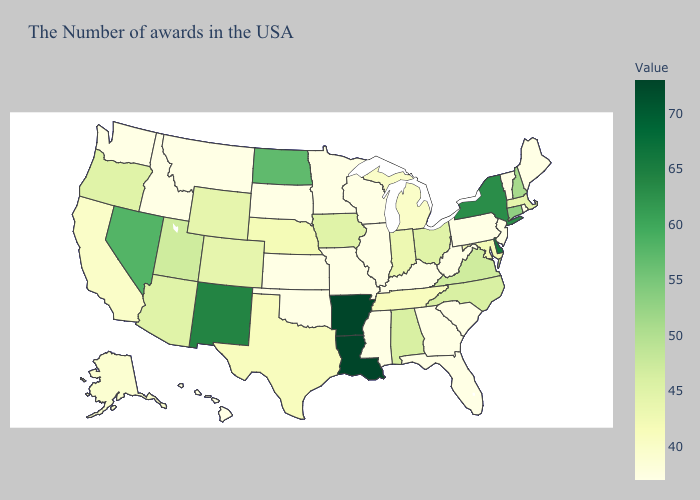Does Iowa have the lowest value in the MidWest?
Keep it brief. No. Which states have the highest value in the USA?
Answer briefly. Louisiana, Arkansas. Among the states that border Oregon , does Nevada have the highest value?
Concise answer only. Yes. Does the map have missing data?
Quick response, please. No. Does Mississippi have a higher value than Nevada?
Short answer required. No. Among the states that border Massachusetts , which have the highest value?
Concise answer only. New York. 